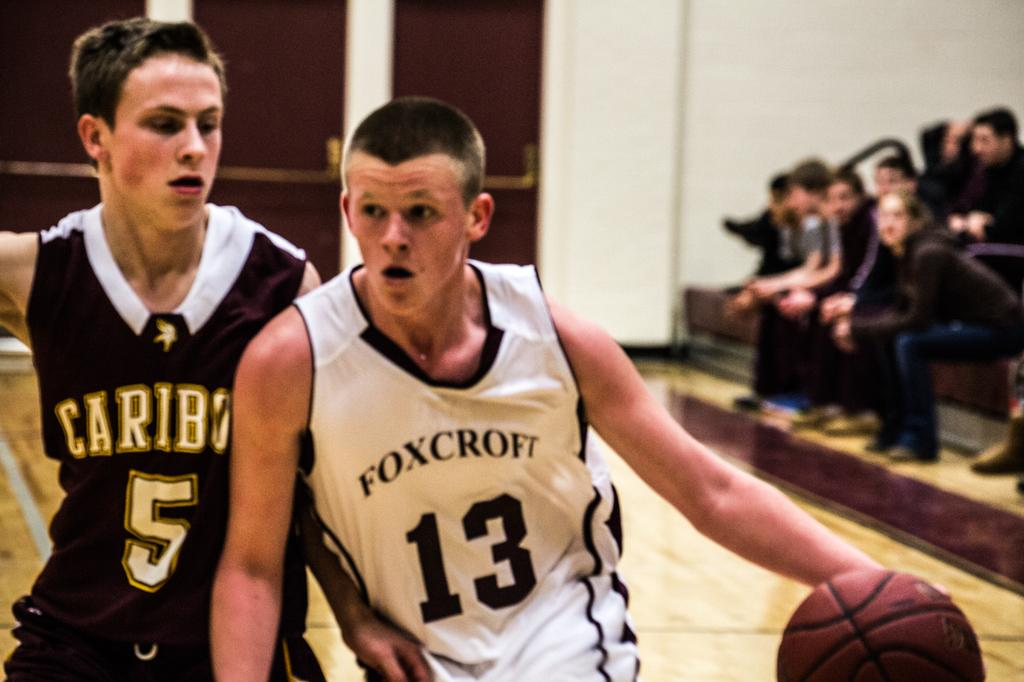<image>
Render a clear and concise summary of the photo. Two basketball players are on a court, one with Caribou on his jersey and the other with Foxcroft on his. 